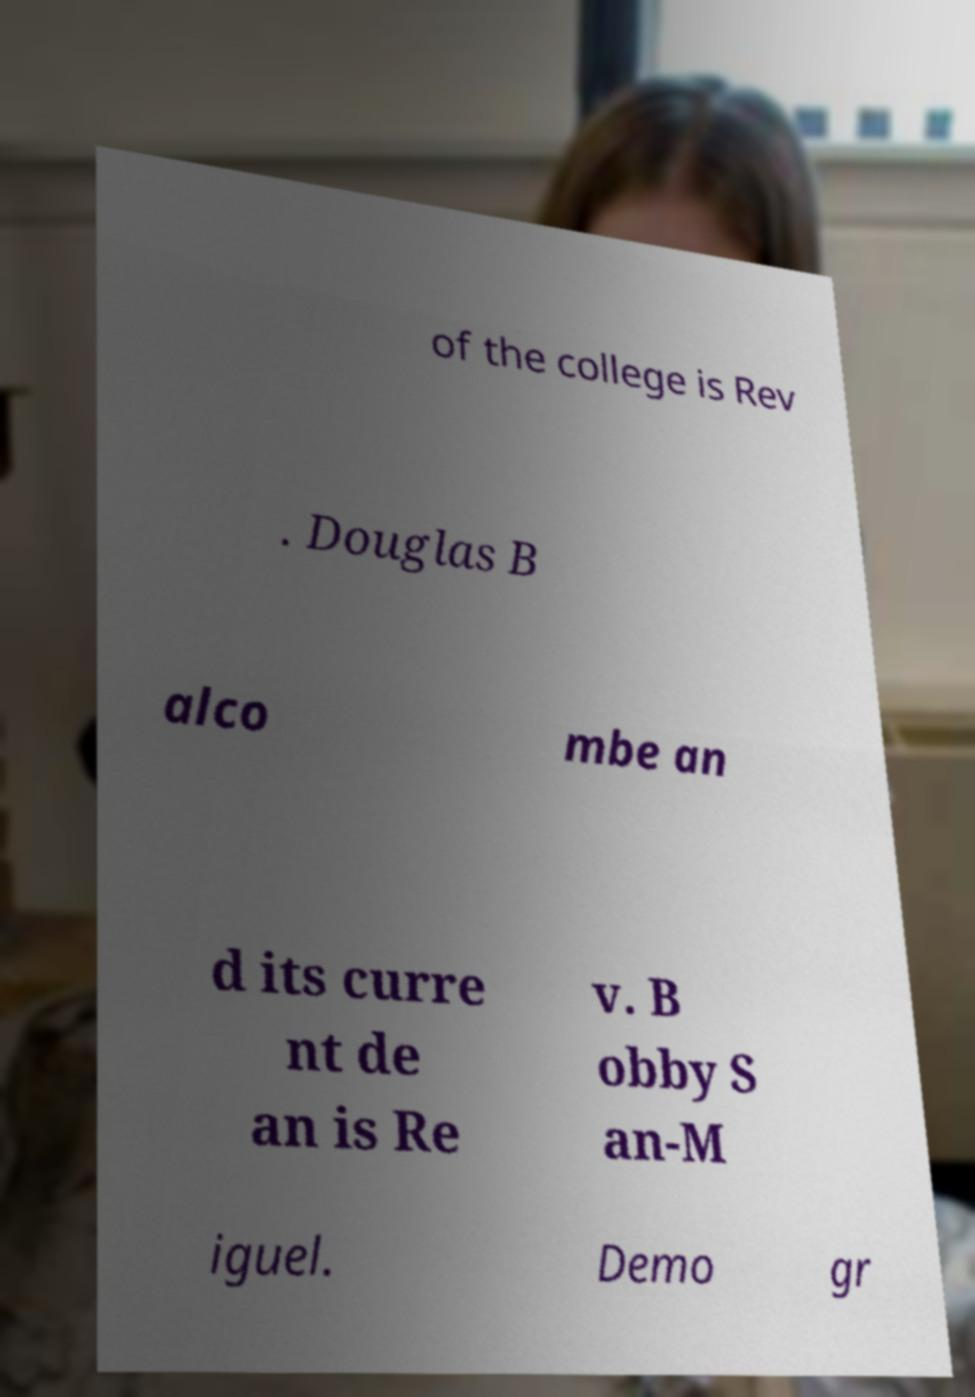Can you read and provide the text displayed in the image?This photo seems to have some interesting text. Can you extract and type it out for me? of the college is Rev . Douglas B alco mbe an d its curre nt de an is Re v. B obby S an-M iguel. Demo gr 